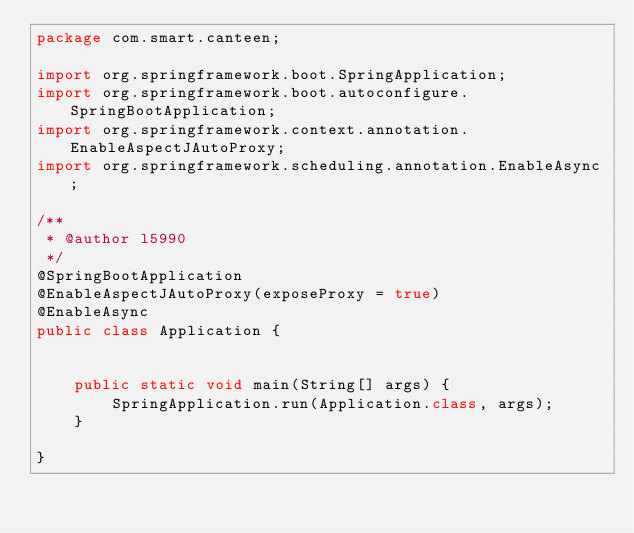<code> <loc_0><loc_0><loc_500><loc_500><_Java_>package com.smart.canteen;

import org.springframework.boot.SpringApplication;
import org.springframework.boot.autoconfigure.SpringBootApplication;
import org.springframework.context.annotation.EnableAspectJAutoProxy;
import org.springframework.scheduling.annotation.EnableAsync;

/**
 * @author l5990
 */
@SpringBootApplication
@EnableAspectJAutoProxy(exposeProxy = true)
@EnableAsync
public class Application {


    public static void main(String[] args) {
        SpringApplication.run(Application.class, args);
    }

}
</code> 